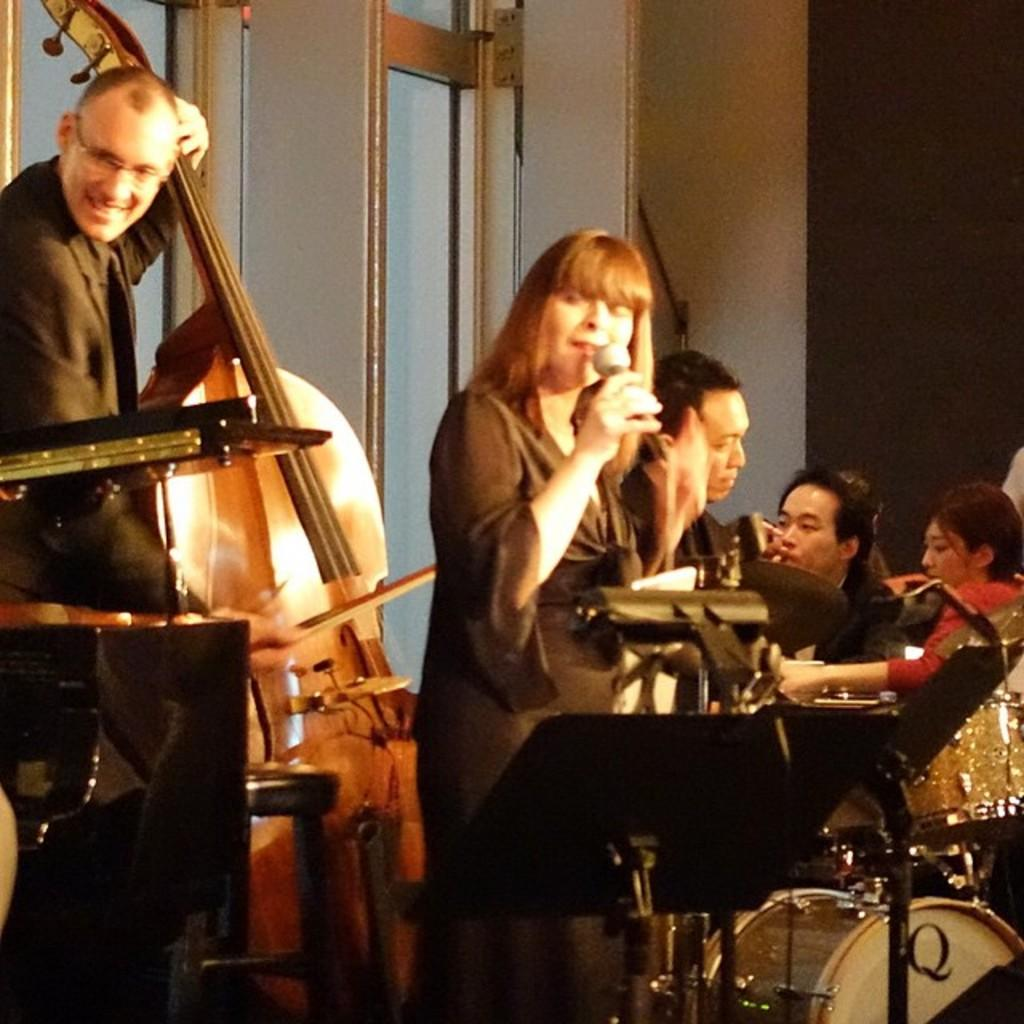What are the people in the image doing? The people in the image are sitting. Are there any standing individuals in the image? Yes, there is a man and a woman standing in the image. What can be seen in the image related to music? There are musical instruments in the image. What type of structure is visible in the image? There is a wall in the image. What architectural feature allows light and air into the space? There are windows in the image. What type of car is parked in front of the wall in the image? There is no car present in the image; it only features people, musical instruments, a wall, and windows. 